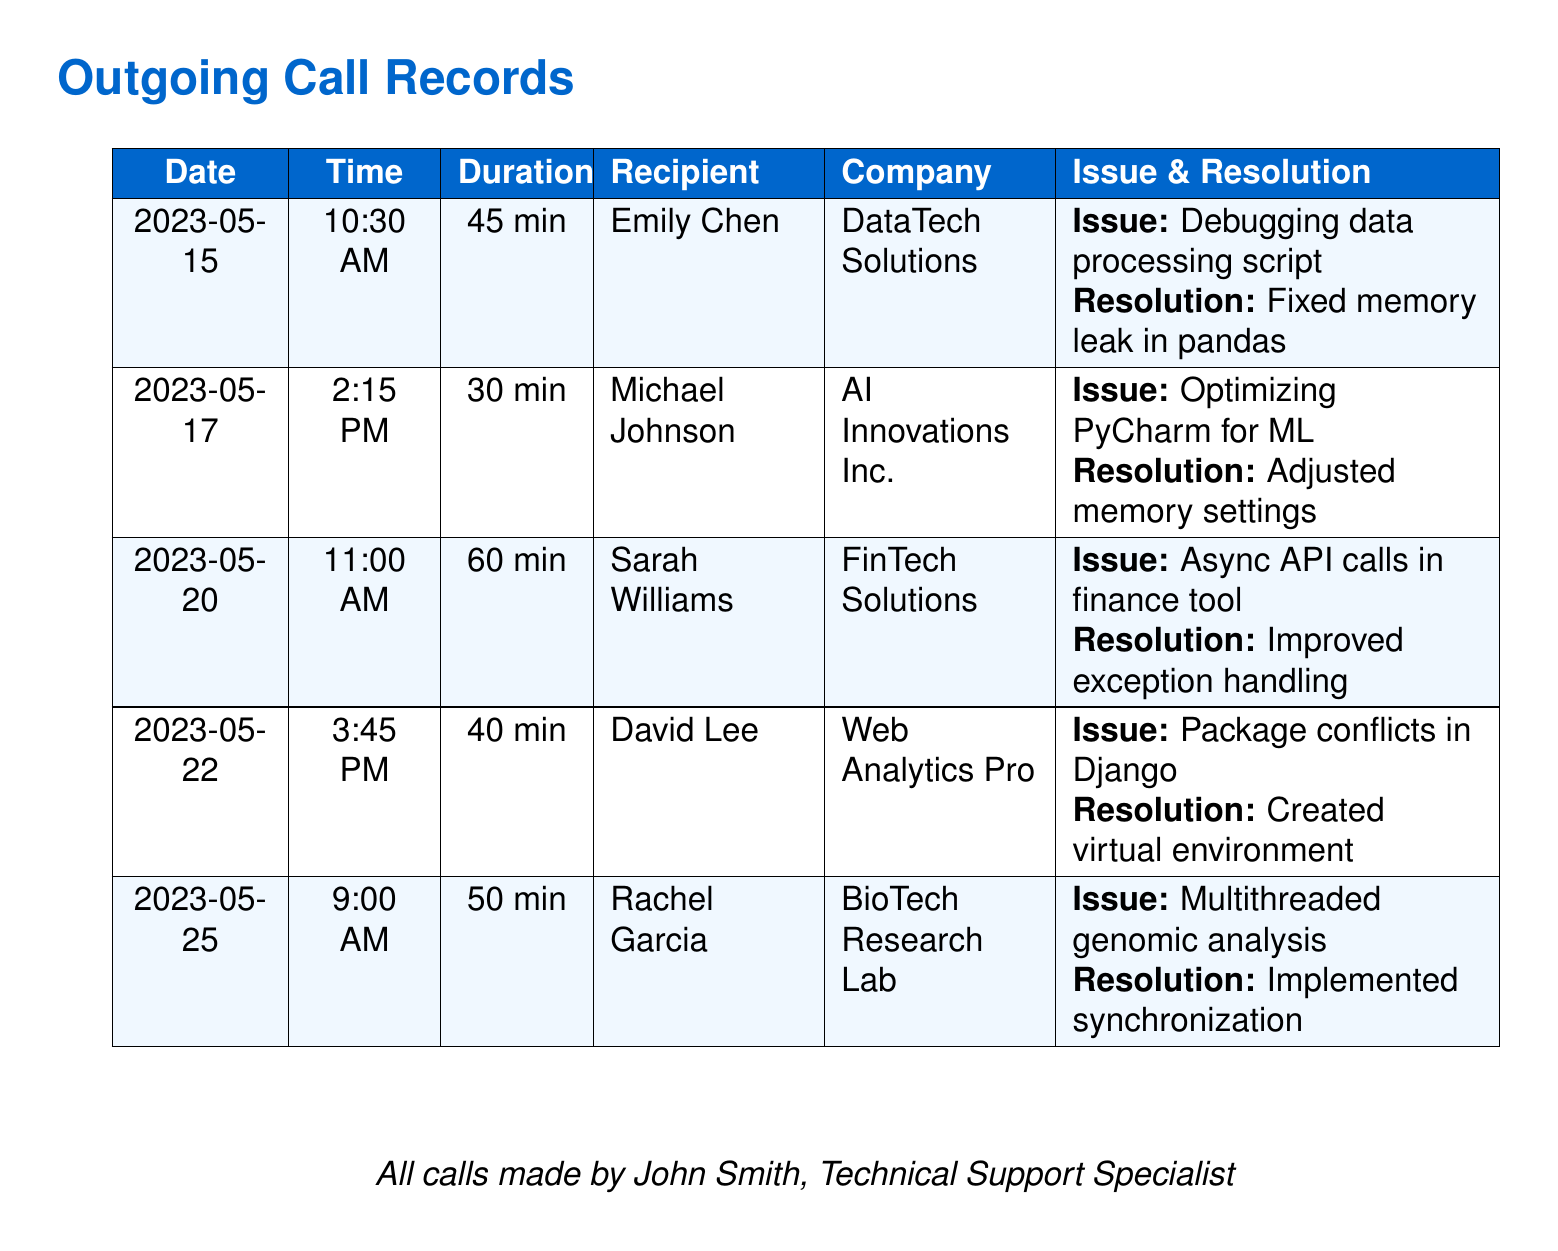What is the date of the first call? The first call recorded in the document is dated May 15, 2023.
Answer: May 15, 2023 Who was the recipient of the call on May 22? The recipient of the call on May 22, 2023, is David Lee.
Answer: David Lee What was the duration of the call with Sarah Williams? The duration of the call with Sarah Williams was 60 minutes.
Answer: 60 min What issue was addressed during the call with Rachel Garcia? The issue addressed during the call with Rachel Garcia was related to multithreaded genomic analysis.
Answer: Multithreaded genomic analysis How many calls were made in total? The document lists a total of five outgoing calls made by John Smith.
Answer: 5 What was the resolution for the call with Emily Chen? The resolution for the call with Emily Chen was fixing a memory leak in pandas.
Answer: Fixed memory leak in pandas Which company was associated with the call about optimizing PyCharm for ML? The company associated with the call about optimizing PyCharm for ML was AI Innovations Inc.
Answer: AI Innovations Inc Which call lasted the longest? The call that lasted the longest was with Sarah Williams, which was 60 minutes.
Answer: 60 min 